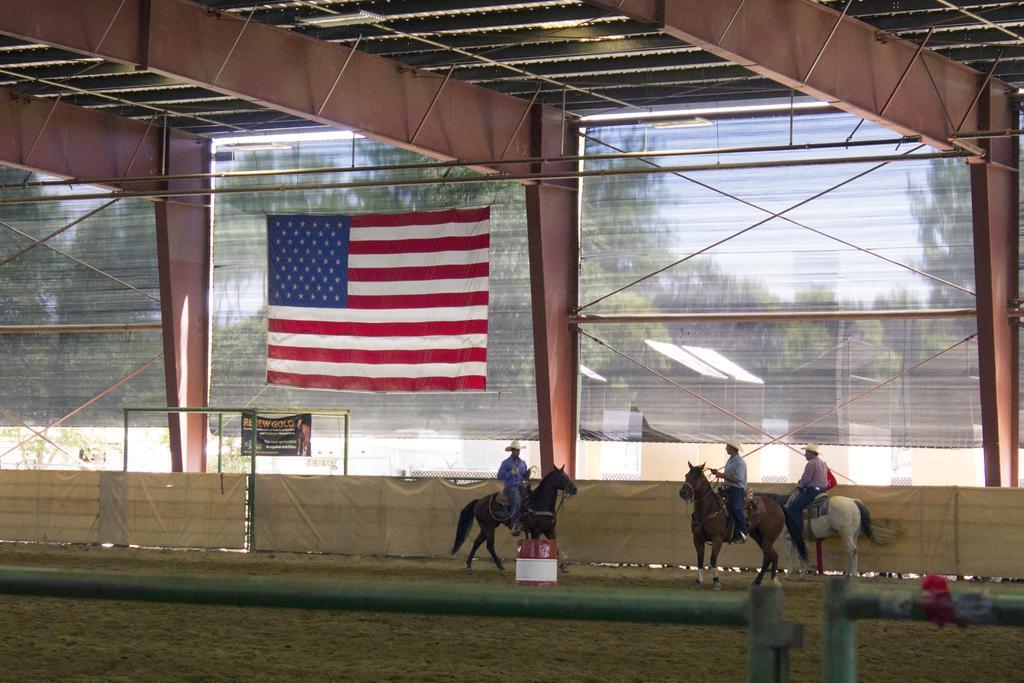Could you give a brief overview of what you see in this image? Three persons are riding horses as we can see at the bottom of this image. We can see a glass wall, flag and trees in the middle of this image. We can see roof at the top of this image. 